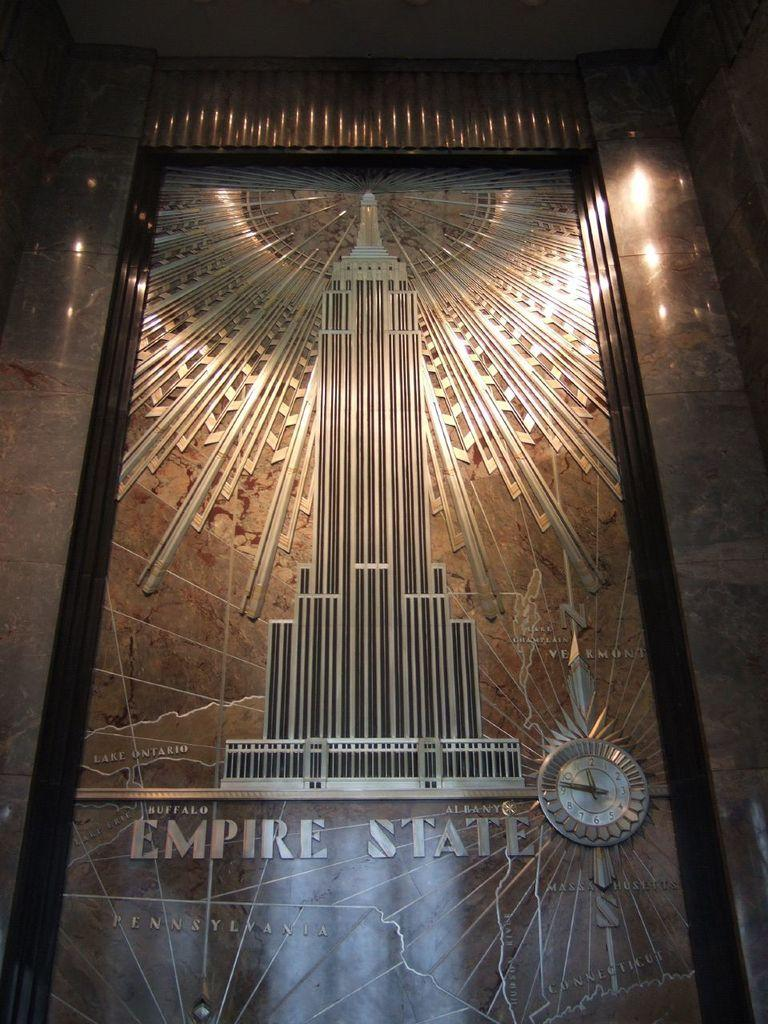<image>
Share a concise interpretation of the image provided. An ornate elevator door has Empire State on it with a rendering of the building. 